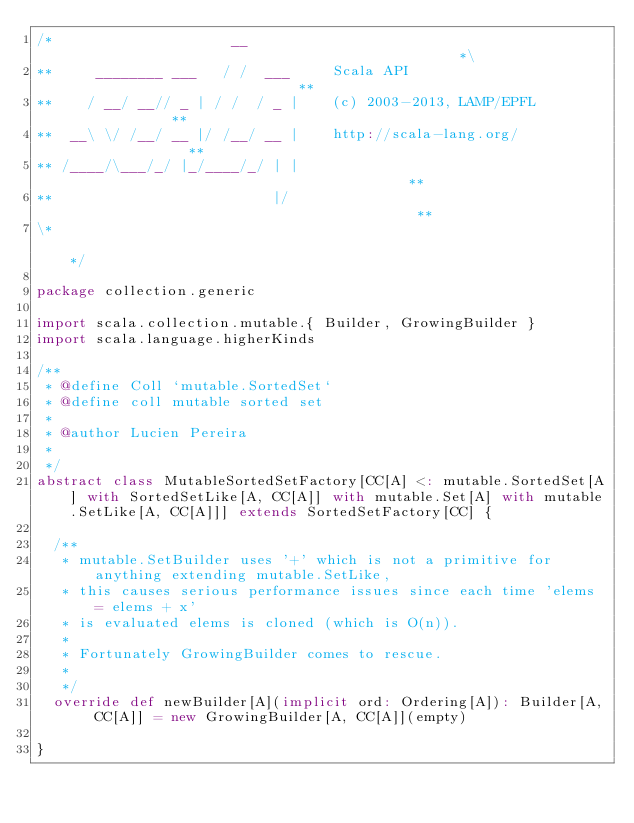<code> <loc_0><loc_0><loc_500><loc_500><_Scala_>/*                     __                                               *\
**     ________ ___   / /  ___     Scala API                            **
**    / __/ __// _ | / /  / _ |    (c) 2003-2013, LAMP/EPFL             **
**  __\ \/ /__/ __ |/ /__/ __ |    http://scala-lang.org/               **
** /____/\___/_/ |_/____/_/ | |                                         **
**                          |/                                          **
\*                                                                      */

package collection.generic

import scala.collection.mutable.{ Builder, GrowingBuilder }
import scala.language.higherKinds

/**
 * @define Coll `mutable.SortedSet`
 * @define coll mutable sorted set
 *
 * @author Lucien Pereira
 *
 */
abstract class MutableSortedSetFactory[CC[A] <: mutable.SortedSet[A] with SortedSetLike[A, CC[A]] with mutable.Set[A] with mutable.SetLike[A, CC[A]]] extends SortedSetFactory[CC] {

  /**
   * mutable.SetBuilder uses '+' which is not a primitive for anything extending mutable.SetLike,
   * this causes serious performance issues since each time 'elems = elems + x'
   * is evaluated elems is cloned (which is O(n)).
   *
   * Fortunately GrowingBuilder comes to rescue.
   *
   */
  override def newBuilder[A](implicit ord: Ordering[A]): Builder[A, CC[A]] = new GrowingBuilder[A, CC[A]](empty)

}
</code> 